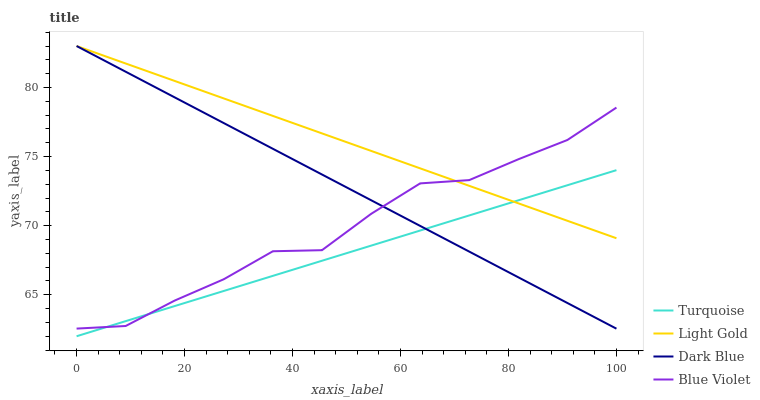Does Turquoise have the minimum area under the curve?
Answer yes or no. Yes. Does Light Gold have the maximum area under the curve?
Answer yes or no. Yes. Does Light Gold have the minimum area under the curve?
Answer yes or no. No. Does Turquoise have the maximum area under the curve?
Answer yes or no. No. Is Dark Blue the smoothest?
Answer yes or no. Yes. Is Blue Violet the roughest?
Answer yes or no. Yes. Is Turquoise the smoothest?
Answer yes or no. No. Is Turquoise the roughest?
Answer yes or no. No. Does Turquoise have the lowest value?
Answer yes or no. Yes. Does Light Gold have the lowest value?
Answer yes or no. No. Does Light Gold have the highest value?
Answer yes or no. Yes. Does Turquoise have the highest value?
Answer yes or no. No. Does Dark Blue intersect Blue Violet?
Answer yes or no. Yes. Is Dark Blue less than Blue Violet?
Answer yes or no. No. Is Dark Blue greater than Blue Violet?
Answer yes or no. No. 